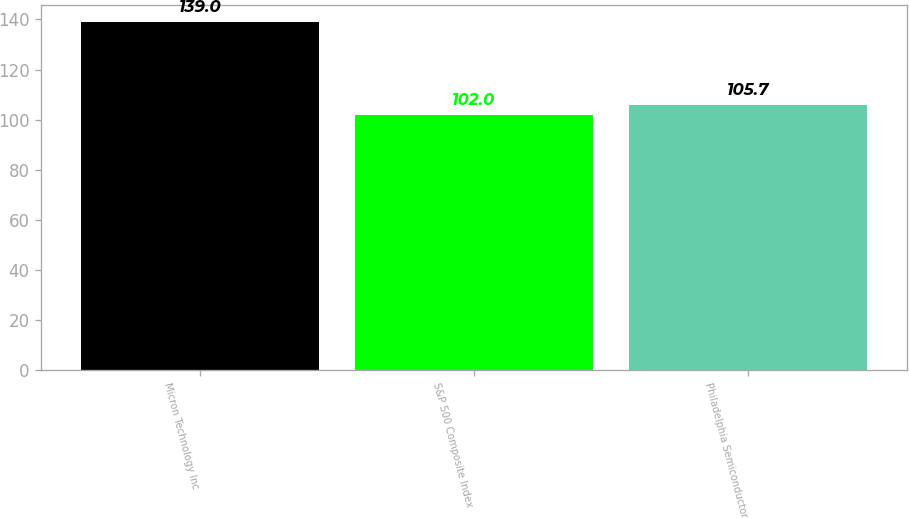<chart> <loc_0><loc_0><loc_500><loc_500><bar_chart><fcel>Micron Technology Inc<fcel>S&P 500 Composite Index<fcel>Philadelphia Semiconductor<nl><fcel>139<fcel>102<fcel>105.7<nl></chart> 